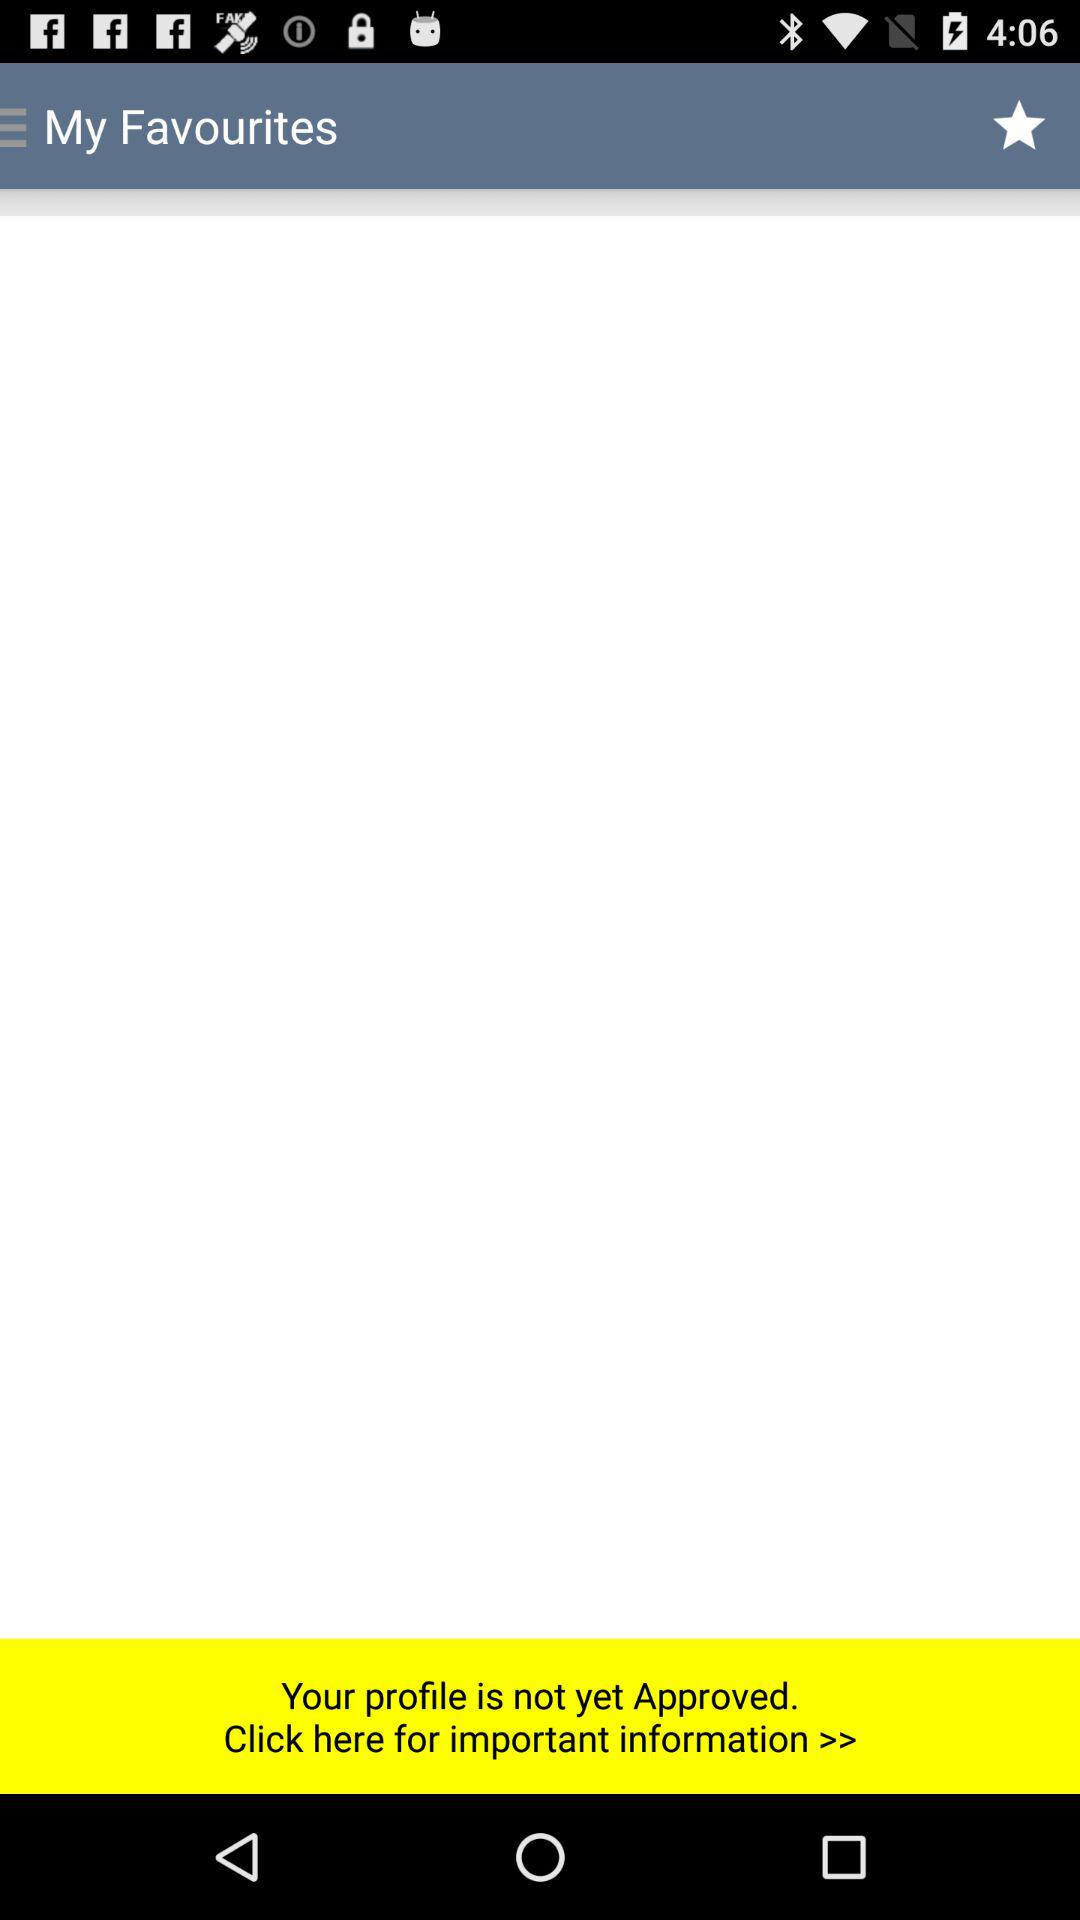What is the application name?
When the provided information is insufficient, respond with <no answer>. <no answer> 